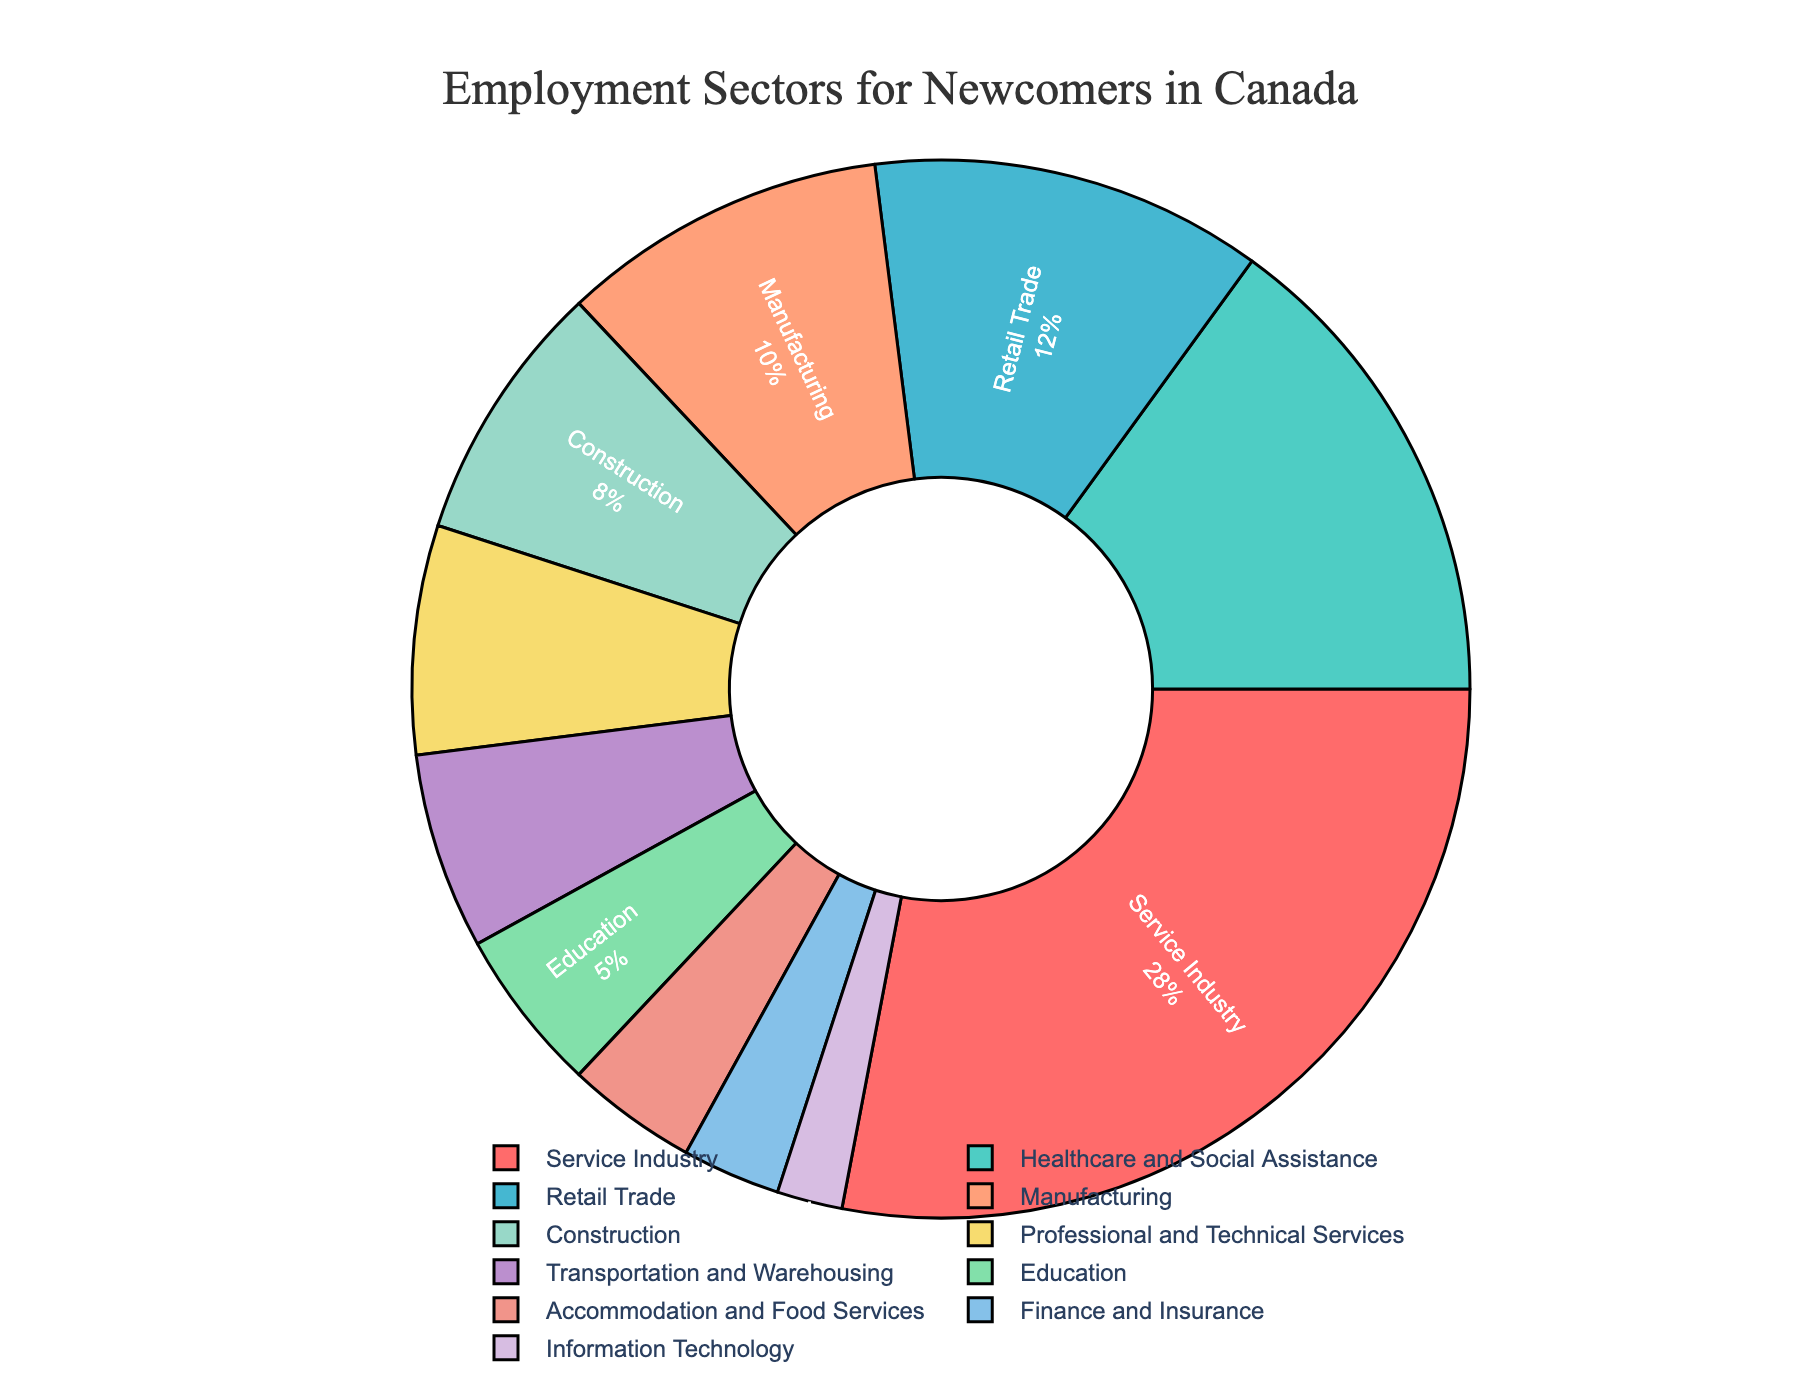What is the largest employment sector for newcomers in Canada? To determine the largest employment sector, look at the sector with the largest percentage in the pie chart. The "Service Industry" has the highest percentage at 28%.
Answer: Service Industry What are the top three sectors for newcomer employment by percentage? Identify the three sectors with the highest percentages. The top three sectors are "Service Industry" (28%), "Healthcare and Social Assistance" (15%), and "Retail Trade" (12%).
Answer: Service Industry, Healthcare and Social Assistance, Retail Trade How much greater is the percentage of newcomers in the Service Industry compared to those in Healthcare and Social Assistance? Subtract the percentage of Healthcare and Social Assistance (15%) from the percentage of the Service Industry (28%). The difference is 28% - 15% = 13%.
Answer: 13% What is the combined percentage of newcomers in Retail Trade, Manufacturing, and Construction sectors? Add the percentages of Retail Trade (12%), Manufacturing (10%), and Construction (8%). The combined percentage is 12% + 10% + 8% = 30%.
Answer: 30% Which sector has the smallest percentage of newcomer employment? Look for the sector with the smallest slice in the pie chart. The "Information Technology" sector has the smallest percentage at 2%.
Answer: Information Technology How many sectors have a percentage of newcomer employment greater than 10%? Identify the sectors where the percentage is greater than 10%. The sectors are "Service Industry" (28%), "Healthcare and Social Assistance" (15%), "Retail Trade" (12%), and "Manufacturing" (10%). Since Manufacturing is exactly 10%, it is not included. Thus, there are 3 sectors.
Answer: 3 Compare the percentages of newcomers employed in Education and Accommodation and Food Services. Which one is higher? Look at the chart to compare the percentages of "Education" (5%) and "Accommodation and Food Services" (4%). Education has a higher percentage.
Answer: Education What is the total percentage of newcomers employed in sectors other than Service Industry? Subtract the percentage of the Service Industry (28%) from 100%. The total remaining percentage is 100% - 28% = 72%.
Answer: 72% How much more percentage of newcomers are employed in Retail Trade compared to Transportation and Warehousing? Subtract the percentage of Transportation and Warehousing (6%) from Retail Trade (12%). The difference is 12% - 6% = 6%.
Answer: 6% What percentage of newcomers are employed in Finance and Insurance and Information Technology sectors combined? Add the percentages of Finance and Insurance (3%) and Information Technology (2%). The combined percentage is 3% + 2% = 5%.
Answer: 5% 